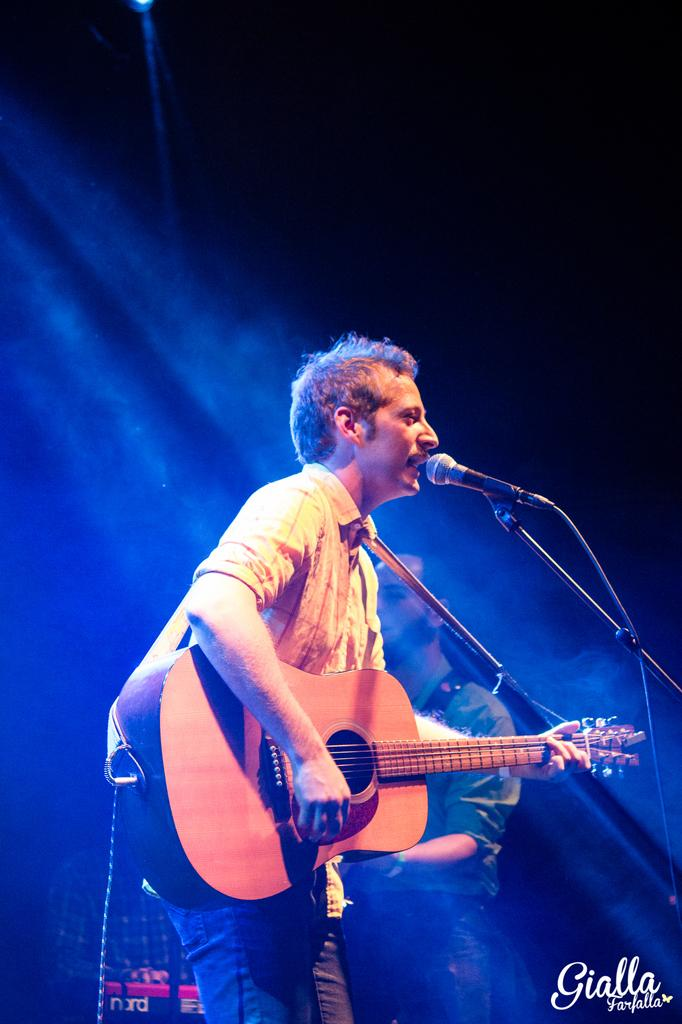What is the main subject of the image? The main subject of the image is a man standing in the middle. What is the man in the middle doing? The man is playing a guitar and singing. Is there anyone else in the image? Yes, there is another man standing behind the first man. What type of paste is being used by the mice in the image? There are no mice or paste present in the image. 